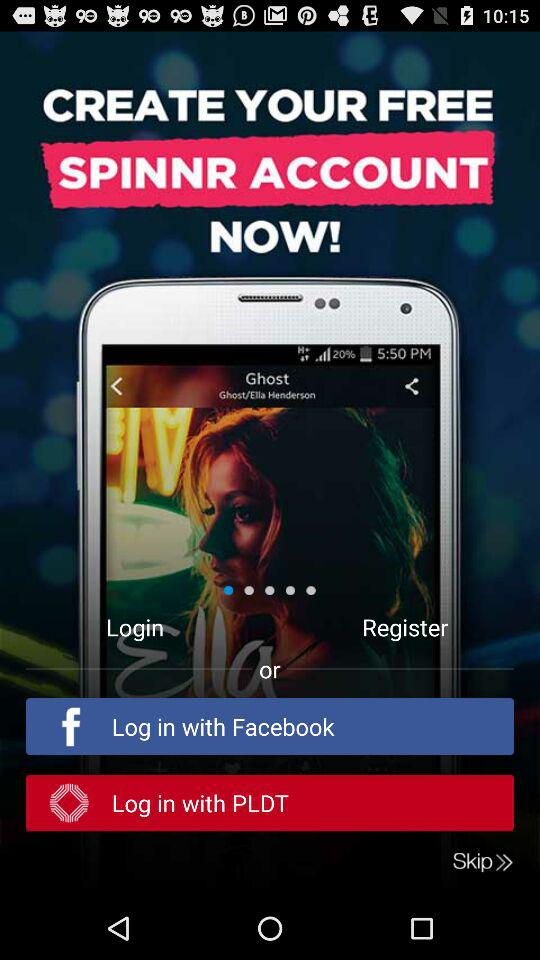What are the different options available for logging in? The different options available for logging in are "Facebook" and "PLDT". 